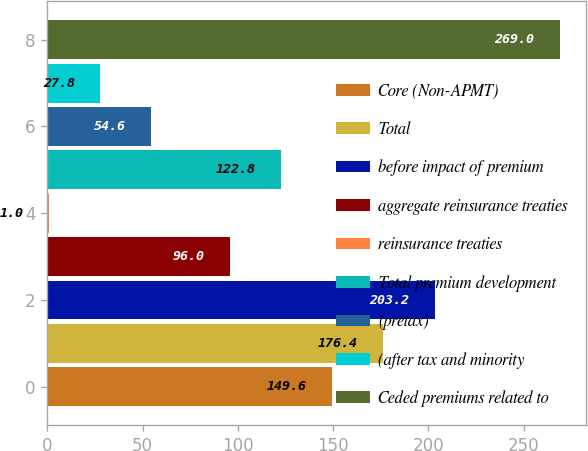Convert chart. <chart><loc_0><loc_0><loc_500><loc_500><bar_chart><fcel>Core (Non-APMT)<fcel>Total<fcel>before impact of premium<fcel>aggregate reinsurance treaties<fcel>reinsurance treaties<fcel>Total premium development<fcel>(pretax)<fcel>(after tax and minority<fcel>Ceded premiums related to<nl><fcel>149.6<fcel>176.4<fcel>203.2<fcel>96<fcel>1<fcel>122.8<fcel>54.6<fcel>27.8<fcel>269<nl></chart> 